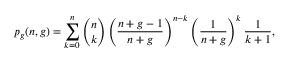<formula> <loc_0><loc_0><loc_500><loc_500>p _ { g } ( n , g ) = \sum _ { k = 0 } ^ { n } \binom { n } { k } \left ( \frac { n + g - 1 } { n + g } \right ) ^ { n - k } \left ( \frac { 1 } { n + g } \right ) ^ { k } \frac { 1 } { k + 1 } ,</formula> 